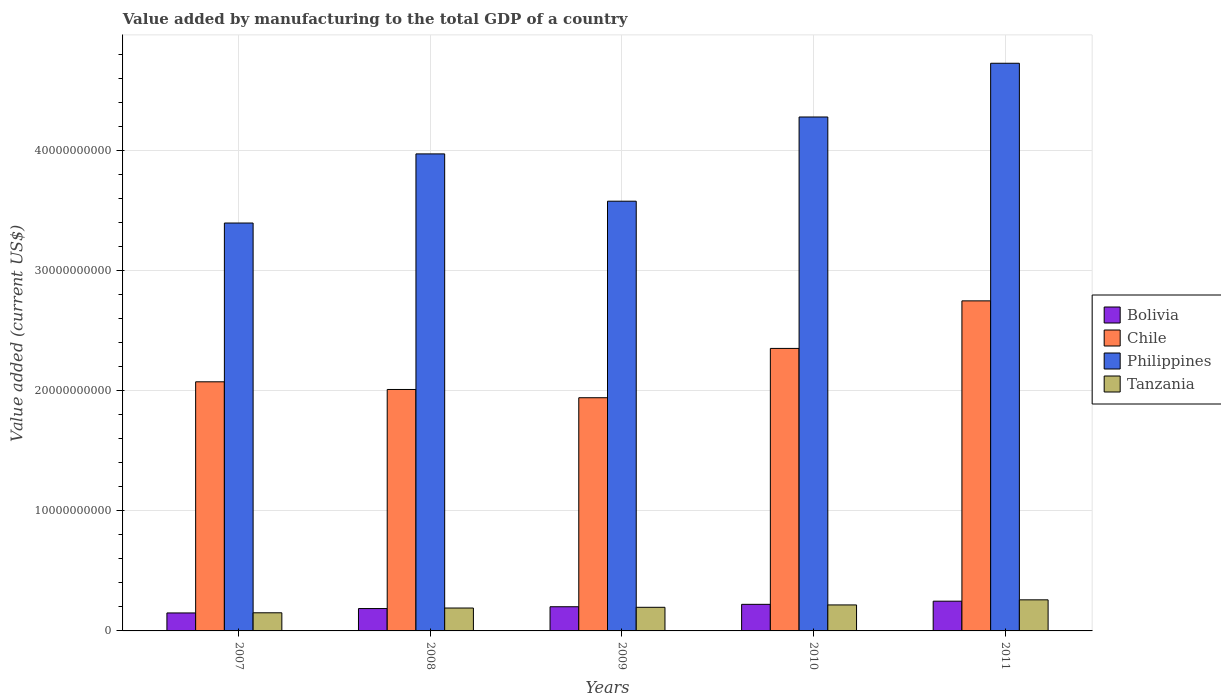How many groups of bars are there?
Provide a short and direct response. 5. Are the number of bars on each tick of the X-axis equal?
Offer a terse response. Yes. In how many cases, is the number of bars for a given year not equal to the number of legend labels?
Make the answer very short. 0. What is the value added by manufacturing to the total GDP in Bolivia in 2011?
Your response must be concise. 2.48e+09. Across all years, what is the maximum value added by manufacturing to the total GDP in Philippines?
Your response must be concise. 4.73e+1. Across all years, what is the minimum value added by manufacturing to the total GDP in Tanzania?
Provide a short and direct response. 1.51e+09. In which year was the value added by manufacturing to the total GDP in Chile maximum?
Ensure brevity in your answer.  2011. In which year was the value added by manufacturing to the total GDP in Bolivia minimum?
Your response must be concise. 2007. What is the total value added by manufacturing to the total GDP in Chile in the graph?
Your answer should be compact. 1.11e+11. What is the difference between the value added by manufacturing to the total GDP in Philippines in 2007 and that in 2010?
Offer a terse response. -8.83e+09. What is the difference between the value added by manufacturing to the total GDP in Chile in 2011 and the value added by manufacturing to the total GDP in Philippines in 2009?
Ensure brevity in your answer.  -8.30e+09. What is the average value added by manufacturing to the total GDP in Philippines per year?
Make the answer very short. 3.99e+1. In the year 2011, what is the difference between the value added by manufacturing to the total GDP in Bolivia and value added by manufacturing to the total GDP in Chile?
Keep it short and to the point. -2.50e+1. What is the ratio of the value added by manufacturing to the total GDP in Philippines in 2007 to that in 2009?
Ensure brevity in your answer.  0.95. Is the value added by manufacturing to the total GDP in Philippines in 2008 less than that in 2010?
Keep it short and to the point. Yes. Is the difference between the value added by manufacturing to the total GDP in Bolivia in 2009 and 2011 greater than the difference between the value added by manufacturing to the total GDP in Chile in 2009 and 2011?
Provide a short and direct response. Yes. What is the difference between the highest and the second highest value added by manufacturing to the total GDP in Chile?
Your response must be concise. 3.96e+09. What is the difference between the highest and the lowest value added by manufacturing to the total GDP in Chile?
Give a very brief answer. 8.07e+09. In how many years, is the value added by manufacturing to the total GDP in Philippines greater than the average value added by manufacturing to the total GDP in Philippines taken over all years?
Offer a terse response. 2. What does the 1st bar from the left in 2010 represents?
Provide a succinct answer. Bolivia. What does the 2nd bar from the right in 2011 represents?
Your answer should be compact. Philippines. Are all the bars in the graph horizontal?
Keep it short and to the point. No. How many years are there in the graph?
Offer a terse response. 5. Are the values on the major ticks of Y-axis written in scientific E-notation?
Provide a succinct answer. No. Does the graph contain grids?
Offer a very short reply. Yes. How many legend labels are there?
Ensure brevity in your answer.  4. How are the legend labels stacked?
Provide a succinct answer. Vertical. What is the title of the graph?
Keep it short and to the point. Value added by manufacturing to the total GDP of a country. What is the label or title of the Y-axis?
Give a very brief answer. Value added (current US$). What is the Value added (current US$) of Bolivia in 2007?
Your response must be concise. 1.50e+09. What is the Value added (current US$) of Chile in 2007?
Your response must be concise. 2.07e+1. What is the Value added (current US$) in Philippines in 2007?
Make the answer very short. 3.40e+1. What is the Value added (current US$) of Tanzania in 2007?
Your answer should be very brief. 1.51e+09. What is the Value added (current US$) in Bolivia in 2008?
Your response must be concise. 1.86e+09. What is the Value added (current US$) in Chile in 2008?
Keep it short and to the point. 2.01e+1. What is the Value added (current US$) in Philippines in 2008?
Offer a very short reply. 3.97e+1. What is the Value added (current US$) of Tanzania in 2008?
Offer a terse response. 1.91e+09. What is the Value added (current US$) in Bolivia in 2009?
Your answer should be very brief. 2.01e+09. What is the Value added (current US$) of Chile in 2009?
Offer a very short reply. 1.94e+1. What is the Value added (current US$) in Philippines in 2009?
Your response must be concise. 3.58e+1. What is the Value added (current US$) of Tanzania in 2009?
Give a very brief answer. 1.97e+09. What is the Value added (current US$) of Bolivia in 2010?
Offer a very short reply. 2.21e+09. What is the Value added (current US$) in Chile in 2010?
Provide a short and direct response. 2.35e+1. What is the Value added (current US$) of Philippines in 2010?
Your answer should be very brief. 4.28e+1. What is the Value added (current US$) of Tanzania in 2010?
Ensure brevity in your answer.  2.16e+09. What is the Value added (current US$) in Bolivia in 2011?
Give a very brief answer. 2.48e+09. What is the Value added (current US$) of Chile in 2011?
Your response must be concise. 2.75e+1. What is the Value added (current US$) in Philippines in 2011?
Keep it short and to the point. 4.73e+1. What is the Value added (current US$) of Tanzania in 2011?
Offer a terse response. 2.59e+09. Across all years, what is the maximum Value added (current US$) of Bolivia?
Your answer should be compact. 2.48e+09. Across all years, what is the maximum Value added (current US$) of Chile?
Provide a succinct answer. 2.75e+1. Across all years, what is the maximum Value added (current US$) of Philippines?
Your response must be concise. 4.73e+1. Across all years, what is the maximum Value added (current US$) of Tanzania?
Your response must be concise. 2.59e+09. Across all years, what is the minimum Value added (current US$) in Bolivia?
Ensure brevity in your answer.  1.50e+09. Across all years, what is the minimum Value added (current US$) of Chile?
Give a very brief answer. 1.94e+1. Across all years, what is the minimum Value added (current US$) in Philippines?
Offer a terse response. 3.40e+1. Across all years, what is the minimum Value added (current US$) in Tanzania?
Keep it short and to the point. 1.51e+09. What is the total Value added (current US$) in Bolivia in the graph?
Provide a short and direct response. 1.01e+1. What is the total Value added (current US$) in Chile in the graph?
Offer a terse response. 1.11e+11. What is the total Value added (current US$) of Philippines in the graph?
Ensure brevity in your answer.  2.00e+11. What is the total Value added (current US$) of Tanzania in the graph?
Your answer should be very brief. 1.01e+1. What is the difference between the Value added (current US$) of Bolivia in 2007 and that in 2008?
Give a very brief answer. -3.65e+08. What is the difference between the Value added (current US$) of Chile in 2007 and that in 2008?
Provide a succinct answer. 6.39e+08. What is the difference between the Value added (current US$) in Philippines in 2007 and that in 2008?
Provide a short and direct response. -5.76e+09. What is the difference between the Value added (current US$) of Tanzania in 2007 and that in 2008?
Provide a short and direct response. -3.97e+08. What is the difference between the Value added (current US$) of Bolivia in 2007 and that in 2009?
Offer a terse response. -5.17e+08. What is the difference between the Value added (current US$) in Chile in 2007 and that in 2009?
Offer a terse response. 1.33e+09. What is the difference between the Value added (current US$) of Philippines in 2007 and that in 2009?
Give a very brief answer. -1.82e+09. What is the difference between the Value added (current US$) in Tanzania in 2007 and that in 2009?
Provide a succinct answer. -4.57e+08. What is the difference between the Value added (current US$) in Bolivia in 2007 and that in 2010?
Keep it short and to the point. -7.17e+08. What is the difference between the Value added (current US$) in Chile in 2007 and that in 2010?
Your response must be concise. -2.78e+09. What is the difference between the Value added (current US$) in Philippines in 2007 and that in 2010?
Ensure brevity in your answer.  -8.83e+09. What is the difference between the Value added (current US$) in Tanzania in 2007 and that in 2010?
Offer a terse response. -6.55e+08. What is the difference between the Value added (current US$) of Bolivia in 2007 and that in 2011?
Offer a terse response. -9.80e+08. What is the difference between the Value added (current US$) of Chile in 2007 and that in 2011?
Ensure brevity in your answer.  -6.74e+09. What is the difference between the Value added (current US$) of Philippines in 2007 and that in 2011?
Make the answer very short. -1.33e+1. What is the difference between the Value added (current US$) in Tanzania in 2007 and that in 2011?
Give a very brief answer. -1.08e+09. What is the difference between the Value added (current US$) of Bolivia in 2008 and that in 2009?
Give a very brief answer. -1.52e+08. What is the difference between the Value added (current US$) in Chile in 2008 and that in 2009?
Your answer should be very brief. 6.88e+08. What is the difference between the Value added (current US$) in Philippines in 2008 and that in 2009?
Offer a very short reply. 3.94e+09. What is the difference between the Value added (current US$) in Tanzania in 2008 and that in 2009?
Offer a very short reply. -5.97e+07. What is the difference between the Value added (current US$) of Bolivia in 2008 and that in 2010?
Make the answer very short. -3.52e+08. What is the difference between the Value added (current US$) of Chile in 2008 and that in 2010?
Keep it short and to the point. -3.42e+09. What is the difference between the Value added (current US$) of Philippines in 2008 and that in 2010?
Your response must be concise. -3.07e+09. What is the difference between the Value added (current US$) of Tanzania in 2008 and that in 2010?
Give a very brief answer. -2.57e+08. What is the difference between the Value added (current US$) of Bolivia in 2008 and that in 2011?
Offer a terse response. -6.15e+08. What is the difference between the Value added (current US$) in Chile in 2008 and that in 2011?
Offer a terse response. -7.38e+09. What is the difference between the Value added (current US$) of Philippines in 2008 and that in 2011?
Offer a very short reply. -7.55e+09. What is the difference between the Value added (current US$) in Tanzania in 2008 and that in 2011?
Keep it short and to the point. -6.81e+08. What is the difference between the Value added (current US$) in Bolivia in 2009 and that in 2010?
Your answer should be very brief. -2.00e+08. What is the difference between the Value added (current US$) of Chile in 2009 and that in 2010?
Provide a short and direct response. -4.11e+09. What is the difference between the Value added (current US$) of Philippines in 2009 and that in 2010?
Make the answer very short. -7.01e+09. What is the difference between the Value added (current US$) of Tanzania in 2009 and that in 2010?
Your answer should be very brief. -1.98e+08. What is the difference between the Value added (current US$) in Bolivia in 2009 and that in 2011?
Offer a terse response. -4.63e+08. What is the difference between the Value added (current US$) of Chile in 2009 and that in 2011?
Provide a short and direct response. -8.07e+09. What is the difference between the Value added (current US$) in Philippines in 2009 and that in 2011?
Keep it short and to the point. -1.15e+1. What is the difference between the Value added (current US$) in Tanzania in 2009 and that in 2011?
Offer a very short reply. -6.21e+08. What is the difference between the Value added (current US$) in Bolivia in 2010 and that in 2011?
Your response must be concise. -2.63e+08. What is the difference between the Value added (current US$) of Chile in 2010 and that in 2011?
Your answer should be very brief. -3.96e+09. What is the difference between the Value added (current US$) in Philippines in 2010 and that in 2011?
Make the answer very short. -4.48e+09. What is the difference between the Value added (current US$) of Tanzania in 2010 and that in 2011?
Offer a very short reply. -4.24e+08. What is the difference between the Value added (current US$) of Bolivia in 2007 and the Value added (current US$) of Chile in 2008?
Your answer should be very brief. -1.86e+1. What is the difference between the Value added (current US$) of Bolivia in 2007 and the Value added (current US$) of Philippines in 2008?
Your response must be concise. -3.82e+1. What is the difference between the Value added (current US$) of Bolivia in 2007 and the Value added (current US$) of Tanzania in 2008?
Your answer should be very brief. -4.10e+08. What is the difference between the Value added (current US$) in Chile in 2007 and the Value added (current US$) in Philippines in 2008?
Offer a terse response. -1.90e+1. What is the difference between the Value added (current US$) in Chile in 2007 and the Value added (current US$) in Tanzania in 2008?
Keep it short and to the point. 1.88e+1. What is the difference between the Value added (current US$) in Philippines in 2007 and the Value added (current US$) in Tanzania in 2008?
Offer a very short reply. 3.21e+1. What is the difference between the Value added (current US$) in Bolivia in 2007 and the Value added (current US$) in Chile in 2009?
Provide a succinct answer. -1.79e+1. What is the difference between the Value added (current US$) in Bolivia in 2007 and the Value added (current US$) in Philippines in 2009?
Ensure brevity in your answer.  -3.43e+1. What is the difference between the Value added (current US$) in Bolivia in 2007 and the Value added (current US$) in Tanzania in 2009?
Your answer should be very brief. -4.70e+08. What is the difference between the Value added (current US$) of Chile in 2007 and the Value added (current US$) of Philippines in 2009?
Your response must be concise. -1.50e+1. What is the difference between the Value added (current US$) of Chile in 2007 and the Value added (current US$) of Tanzania in 2009?
Offer a very short reply. 1.88e+1. What is the difference between the Value added (current US$) of Philippines in 2007 and the Value added (current US$) of Tanzania in 2009?
Ensure brevity in your answer.  3.20e+1. What is the difference between the Value added (current US$) in Bolivia in 2007 and the Value added (current US$) in Chile in 2010?
Keep it short and to the point. -2.20e+1. What is the difference between the Value added (current US$) of Bolivia in 2007 and the Value added (current US$) of Philippines in 2010?
Keep it short and to the point. -4.13e+1. What is the difference between the Value added (current US$) of Bolivia in 2007 and the Value added (current US$) of Tanzania in 2010?
Keep it short and to the point. -6.67e+08. What is the difference between the Value added (current US$) of Chile in 2007 and the Value added (current US$) of Philippines in 2010?
Your answer should be very brief. -2.21e+1. What is the difference between the Value added (current US$) in Chile in 2007 and the Value added (current US$) in Tanzania in 2010?
Offer a terse response. 1.86e+1. What is the difference between the Value added (current US$) of Philippines in 2007 and the Value added (current US$) of Tanzania in 2010?
Provide a succinct answer. 3.18e+1. What is the difference between the Value added (current US$) in Bolivia in 2007 and the Value added (current US$) in Chile in 2011?
Your answer should be compact. -2.60e+1. What is the difference between the Value added (current US$) in Bolivia in 2007 and the Value added (current US$) in Philippines in 2011?
Offer a very short reply. -4.58e+1. What is the difference between the Value added (current US$) of Bolivia in 2007 and the Value added (current US$) of Tanzania in 2011?
Provide a short and direct response. -1.09e+09. What is the difference between the Value added (current US$) in Chile in 2007 and the Value added (current US$) in Philippines in 2011?
Provide a short and direct response. -2.65e+1. What is the difference between the Value added (current US$) of Chile in 2007 and the Value added (current US$) of Tanzania in 2011?
Your answer should be compact. 1.82e+1. What is the difference between the Value added (current US$) in Philippines in 2007 and the Value added (current US$) in Tanzania in 2011?
Make the answer very short. 3.14e+1. What is the difference between the Value added (current US$) of Bolivia in 2008 and the Value added (current US$) of Chile in 2009?
Ensure brevity in your answer.  -1.76e+1. What is the difference between the Value added (current US$) in Bolivia in 2008 and the Value added (current US$) in Philippines in 2009?
Offer a terse response. -3.39e+1. What is the difference between the Value added (current US$) in Bolivia in 2008 and the Value added (current US$) in Tanzania in 2009?
Keep it short and to the point. -1.05e+08. What is the difference between the Value added (current US$) of Chile in 2008 and the Value added (current US$) of Philippines in 2009?
Keep it short and to the point. -1.57e+1. What is the difference between the Value added (current US$) in Chile in 2008 and the Value added (current US$) in Tanzania in 2009?
Give a very brief answer. 1.81e+1. What is the difference between the Value added (current US$) in Philippines in 2008 and the Value added (current US$) in Tanzania in 2009?
Ensure brevity in your answer.  3.78e+1. What is the difference between the Value added (current US$) of Bolivia in 2008 and the Value added (current US$) of Chile in 2010?
Your answer should be very brief. -2.17e+1. What is the difference between the Value added (current US$) in Bolivia in 2008 and the Value added (current US$) in Philippines in 2010?
Provide a short and direct response. -4.09e+1. What is the difference between the Value added (current US$) of Bolivia in 2008 and the Value added (current US$) of Tanzania in 2010?
Offer a terse response. -3.03e+08. What is the difference between the Value added (current US$) of Chile in 2008 and the Value added (current US$) of Philippines in 2010?
Provide a succinct answer. -2.27e+1. What is the difference between the Value added (current US$) in Chile in 2008 and the Value added (current US$) in Tanzania in 2010?
Give a very brief answer. 1.79e+1. What is the difference between the Value added (current US$) in Philippines in 2008 and the Value added (current US$) in Tanzania in 2010?
Provide a short and direct response. 3.76e+1. What is the difference between the Value added (current US$) in Bolivia in 2008 and the Value added (current US$) in Chile in 2011?
Provide a short and direct response. -2.56e+1. What is the difference between the Value added (current US$) of Bolivia in 2008 and the Value added (current US$) of Philippines in 2011?
Ensure brevity in your answer.  -4.54e+1. What is the difference between the Value added (current US$) of Bolivia in 2008 and the Value added (current US$) of Tanzania in 2011?
Provide a short and direct response. -7.26e+08. What is the difference between the Value added (current US$) of Chile in 2008 and the Value added (current US$) of Philippines in 2011?
Your answer should be compact. -2.72e+1. What is the difference between the Value added (current US$) of Chile in 2008 and the Value added (current US$) of Tanzania in 2011?
Your answer should be very brief. 1.75e+1. What is the difference between the Value added (current US$) of Philippines in 2008 and the Value added (current US$) of Tanzania in 2011?
Provide a succinct answer. 3.71e+1. What is the difference between the Value added (current US$) of Bolivia in 2009 and the Value added (current US$) of Chile in 2010?
Keep it short and to the point. -2.15e+1. What is the difference between the Value added (current US$) of Bolivia in 2009 and the Value added (current US$) of Philippines in 2010?
Provide a succinct answer. -4.08e+1. What is the difference between the Value added (current US$) of Bolivia in 2009 and the Value added (current US$) of Tanzania in 2010?
Provide a succinct answer. -1.51e+08. What is the difference between the Value added (current US$) of Chile in 2009 and the Value added (current US$) of Philippines in 2010?
Ensure brevity in your answer.  -2.34e+1. What is the difference between the Value added (current US$) in Chile in 2009 and the Value added (current US$) in Tanzania in 2010?
Ensure brevity in your answer.  1.73e+1. What is the difference between the Value added (current US$) in Philippines in 2009 and the Value added (current US$) in Tanzania in 2010?
Make the answer very short. 3.36e+1. What is the difference between the Value added (current US$) in Bolivia in 2009 and the Value added (current US$) in Chile in 2011?
Provide a short and direct response. -2.55e+1. What is the difference between the Value added (current US$) in Bolivia in 2009 and the Value added (current US$) in Philippines in 2011?
Provide a short and direct response. -4.53e+1. What is the difference between the Value added (current US$) of Bolivia in 2009 and the Value added (current US$) of Tanzania in 2011?
Ensure brevity in your answer.  -5.74e+08. What is the difference between the Value added (current US$) in Chile in 2009 and the Value added (current US$) in Philippines in 2011?
Offer a terse response. -2.79e+1. What is the difference between the Value added (current US$) in Chile in 2009 and the Value added (current US$) in Tanzania in 2011?
Provide a short and direct response. 1.68e+1. What is the difference between the Value added (current US$) of Philippines in 2009 and the Value added (current US$) of Tanzania in 2011?
Keep it short and to the point. 3.32e+1. What is the difference between the Value added (current US$) in Bolivia in 2010 and the Value added (current US$) in Chile in 2011?
Offer a very short reply. -2.53e+1. What is the difference between the Value added (current US$) of Bolivia in 2010 and the Value added (current US$) of Philippines in 2011?
Offer a very short reply. -4.51e+1. What is the difference between the Value added (current US$) in Bolivia in 2010 and the Value added (current US$) in Tanzania in 2011?
Offer a very short reply. -3.74e+08. What is the difference between the Value added (current US$) of Chile in 2010 and the Value added (current US$) of Philippines in 2011?
Provide a short and direct response. -2.37e+1. What is the difference between the Value added (current US$) of Chile in 2010 and the Value added (current US$) of Tanzania in 2011?
Your response must be concise. 2.09e+1. What is the difference between the Value added (current US$) of Philippines in 2010 and the Value added (current US$) of Tanzania in 2011?
Your answer should be very brief. 4.02e+1. What is the average Value added (current US$) in Bolivia per year?
Your answer should be very brief. 2.01e+09. What is the average Value added (current US$) of Chile per year?
Ensure brevity in your answer.  2.23e+1. What is the average Value added (current US$) in Philippines per year?
Your response must be concise. 3.99e+1. What is the average Value added (current US$) in Tanzania per year?
Offer a terse response. 2.03e+09. In the year 2007, what is the difference between the Value added (current US$) of Bolivia and Value added (current US$) of Chile?
Offer a terse response. -1.92e+1. In the year 2007, what is the difference between the Value added (current US$) in Bolivia and Value added (current US$) in Philippines?
Your response must be concise. -3.25e+1. In the year 2007, what is the difference between the Value added (current US$) in Bolivia and Value added (current US$) in Tanzania?
Your response must be concise. -1.24e+07. In the year 2007, what is the difference between the Value added (current US$) in Chile and Value added (current US$) in Philippines?
Provide a succinct answer. -1.32e+1. In the year 2007, what is the difference between the Value added (current US$) in Chile and Value added (current US$) in Tanzania?
Your response must be concise. 1.92e+1. In the year 2007, what is the difference between the Value added (current US$) of Philippines and Value added (current US$) of Tanzania?
Your answer should be very brief. 3.25e+1. In the year 2008, what is the difference between the Value added (current US$) in Bolivia and Value added (current US$) in Chile?
Provide a succinct answer. -1.82e+1. In the year 2008, what is the difference between the Value added (current US$) in Bolivia and Value added (current US$) in Philippines?
Your answer should be very brief. -3.79e+1. In the year 2008, what is the difference between the Value added (current US$) of Bolivia and Value added (current US$) of Tanzania?
Your response must be concise. -4.52e+07. In the year 2008, what is the difference between the Value added (current US$) in Chile and Value added (current US$) in Philippines?
Your answer should be compact. -1.96e+1. In the year 2008, what is the difference between the Value added (current US$) of Chile and Value added (current US$) of Tanzania?
Provide a short and direct response. 1.82e+1. In the year 2008, what is the difference between the Value added (current US$) of Philippines and Value added (current US$) of Tanzania?
Provide a succinct answer. 3.78e+1. In the year 2009, what is the difference between the Value added (current US$) in Bolivia and Value added (current US$) in Chile?
Keep it short and to the point. -1.74e+1. In the year 2009, what is the difference between the Value added (current US$) of Bolivia and Value added (current US$) of Philippines?
Offer a very short reply. -3.38e+1. In the year 2009, what is the difference between the Value added (current US$) in Bolivia and Value added (current US$) in Tanzania?
Give a very brief answer. 4.72e+07. In the year 2009, what is the difference between the Value added (current US$) in Chile and Value added (current US$) in Philippines?
Provide a succinct answer. -1.64e+1. In the year 2009, what is the difference between the Value added (current US$) of Chile and Value added (current US$) of Tanzania?
Ensure brevity in your answer.  1.75e+1. In the year 2009, what is the difference between the Value added (current US$) in Philippines and Value added (current US$) in Tanzania?
Make the answer very short. 3.38e+1. In the year 2010, what is the difference between the Value added (current US$) of Bolivia and Value added (current US$) of Chile?
Ensure brevity in your answer.  -2.13e+1. In the year 2010, what is the difference between the Value added (current US$) of Bolivia and Value added (current US$) of Philippines?
Your answer should be compact. -4.06e+1. In the year 2010, what is the difference between the Value added (current US$) in Bolivia and Value added (current US$) in Tanzania?
Make the answer very short. 4.96e+07. In the year 2010, what is the difference between the Value added (current US$) in Chile and Value added (current US$) in Philippines?
Keep it short and to the point. -1.93e+1. In the year 2010, what is the difference between the Value added (current US$) in Chile and Value added (current US$) in Tanzania?
Provide a short and direct response. 2.14e+1. In the year 2010, what is the difference between the Value added (current US$) of Philippines and Value added (current US$) of Tanzania?
Ensure brevity in your answer.  4.06e+1. In the year 2011, what is the difference between the Value added (current US$) in Bolivia and Value added (current US$) in Chile?
Your answer should be compact. -2.50e+1. In the year 2011, what is the difference between the Value added (current US$) in Bolivia and Value added (current US$) in Philippines?
Ensure brevity in your answer.  -4.48e+1. In the year 2011, what is the difference between the Value added (current US$) of Bolivia and Value added (current US$) of Tanzania?
Make the answer very short. -1.11e+08. In the year 2011, what is the difference between the Value added (current US$) in Chile and Value added (current US$) in Philippines?
Your answer should be very brief. -1.98e+1. In the year 2011, what is the difference between the Value added (current US$) of Chile and Value added (current US$) of Tanzania?
Offer a terse response. 2.49e+1. In the year 2011, what is the difference between the Value added (current US$) in Philippines and Value added (current US$) in Tanzania?
Ensure brevity in your answer.  4.47e+1. What is the ratio of the Value added (current US$) of Bolivia in 2007 to that in 2008?
Your answer should be compact. 0.8. What is the ratio of the Value added (current US$) of Chile in 2007 to that in 2008?
Your answer should be compact. 1.03. What is the ratio of the Value added (current US$) in Philippines in 2007 to that in 2008?
Give a very brief answer. 0.86. What is the ratio of the Value added (current US$) of Tanzania in 2007 to that in 2008?
Make the answer very short. 0.79. What is the ratio of the Value added (current US$) in Bolivia in 2007 to that in 2009?
Your answer should be compact. 0.74. What is the ratio of the Value added (current US$) in Chile in 2007 to that in 2009?
Offer a terse response. 1.07. What is the ratio of the Value added (current US$) in Philippines in 2007 to that in 2009?
Provide a short and direct response. 0.95. What is the ratio of the Value added (current US$) in Tanzania in 2007 to that in 2009?
Keep it short and to the point. 0.77. What is the ratio of the Value added (current US$) of Bolivia in 2007 to that in 2010?
Ensure brevity in your answer.  0.68. What is the ratio of the Value added (current US$) in Chile in 2007 to that in 2010?
Provide a succinct answer. 0.88. What is the ratio of the Value added (current US$) in Philippines in 2007 to that in 2010?
Your response must be concise. 0.79. What is the ratio of the Value added (current US$) in Tanzania in 2007 to that in 2010?
Provide a short and direct response. 0.7. What is the ratio of the Value added (current US$) of Bolivia in 2007 to that in 2011?
Give a very brief answer. 0.6. What is the ratio of the Value added (current US$) of Chile in 2007 to that in 2011?
Your response must be concise. 0.75. What is the ratio of the Value added (current US$) in Philippines in 2007 to that in 2011?
Keep it short and to the point. 0.72. What is the ratio of the Value added (current US$) in Tanzania in 2007 to that in 2011?
Keep it short and to the point. 0.58. What is the ratio of the Value added (current US$) of Bolivia in 2008 to that in 2009?
Make the answer very short. 0.92. What is the ratio of the Value added (current US$) in Chile in 2008 to that in 2009?
Offer a very short reply. 1.04. What is the ratio of the Value added (current US$) in Philippines in 2008 to that in 2009?
Provide a succinct answer. 1.11. What is the ratio of the Value added (current US$) of Tanzania in 2008 to that in 2009?
Offer a terse response. 0.97. What is the ratio of the Value added (current US$) of Bolivia in 2008 to that in 2010?
Provide a short and direct response. 0.84. What is the ratio of the Value added (current US$) in Chile in 2008 to that in 2010?
Your response must be concise. 0.85. What is the ratio of the Value added (current US$) of Philippines in 2008 to that in 2010?
Make the answer very short. 0.93. What is the ratio of the Value added (current US$) of Tanzania in 2008 to that in 2010?
Provide a succinct answer. 0.88. What is the ratio of the Value added (current US$) of Bolivia in 2008 to that in 2011?
Your response must be concise. 0.75. What is the ratio of the Value added (current US$) in Chile in 2008 to that in 2011?
Offer a terse response. 0.73. What is the ratio of the Value added (current US$) of Philippines in 2008 to that in 2011?
Your answer should be compact. 0.84. What is the ratio of the Value added (current US$) in Tanzania in 2008 to that in 2011?
Provide a succinct answer. 0.74. What is the ratio of the Value added (current US$) in Bolivia in 2009 to that in 2010?
Ensure brevity in your answer.  0.91. What is the ratio of the Value added (current US$) of Chile in 2009 to that in 2010?
Offer a terse response. 0.83. What is the ratio of the Value added (current US$) of Philippines in 2009 to that in 2010?
Make the answer very short. 0.84. What is the ratio of the Value added (current US$) in Tanzania in 2009 to that in 2010?
Give a very brief answer. 0.91. What is the ratio of the Value added (current US$) of Bolivia in 2009 to that in 2011?
Your answer should be very brief. 0.81. What is the ratio of the Value added (current US$) of Chile in 2009 to that in 2011?
Offer a very short reply. 0.71. What is the ratio of the Value added (current US$) in Philippines in 2009 to that in 2011?
Your response must be concise. 0.76. What is the ratio of the Value added (current US$) in Tanzania in 2009 to that in 2011?
Keep it short and to the point. 0.76. What is the ratio of the Value added (current US$) in Bolivia in 2010 to that in 2011?
Your answer should be compact. 0.89. What is the ratio of the Value added (current US$) of Chile in 2010 to that in 2011?
Keep it short and to the point. 0.86. What is the ratio of the Value added (current US$) of Philippines in 2010 to that in 2011?
Your answer should be very brief. 0.91. What is the ratio of the Value added (current US$) of Tanzania in 2010 to that in 2011?
Offer a terse response. 0.84. What is the difference between the highest and the second highest Value added (current US$) of Bolivia?
Make the answer very short. 2.63e+08. What is the difference between the highest and the second highest Value added (current US$) in Chile?
Your answer should be compact. 3.96e+09. What is the difference between the highest and the second highest Value added (current US$) in Philippines?
Keep it short and to the point. 4.48e+09. What is the difference between the highest and the second highest Value added (current US$) in Tanzania?
Give a very brief answer. 4.24e+08. What is the difference between the highest and the lowest Value added (current US$) in Bolivia?
Keep it short and to the point. 9.80e+08. What is the difference between the highest and the lowest Value added (current US$) of Chile?
Your response must be concise. 8.07e+09. What is the difference between the highest and the lowest Value added (current US$) in Philippines?
Provide a succinct answer. 1.33e+1. What is the difference between the highest and the lowest Value added (current US$) of Tanzania?
Offer a terse response. 1.08e+09. 